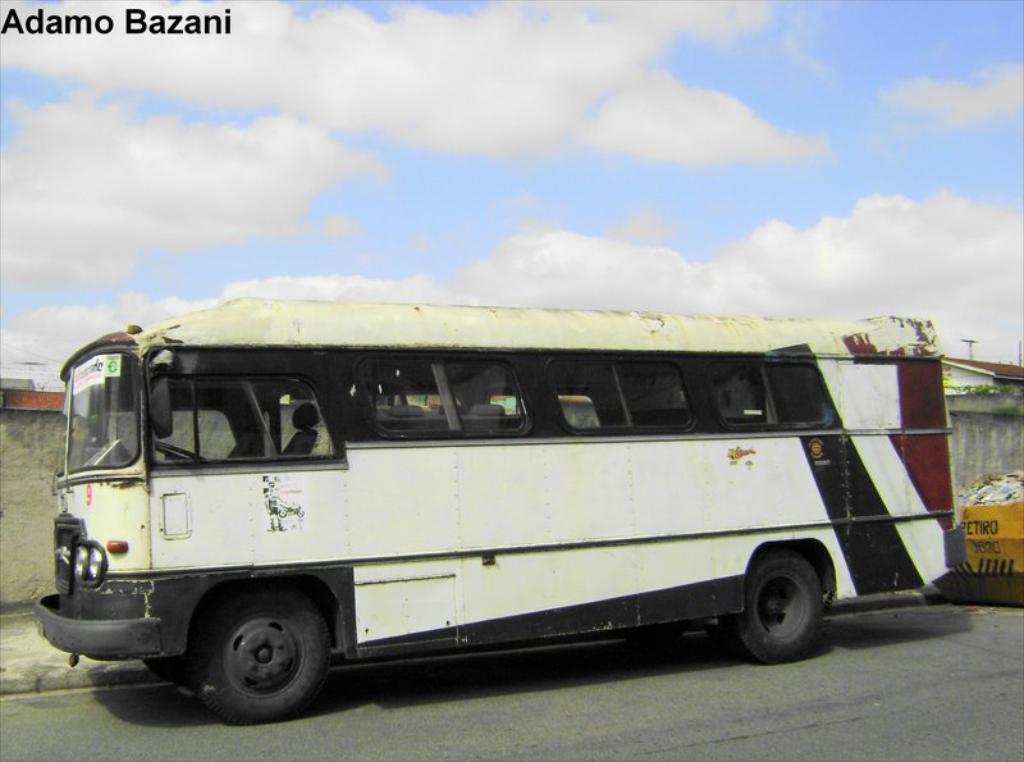Could you give a brief overview of what you see in this image? In this image in the middle there is a bus. At the bottom there is a road. In the background there are houses, wall, garbage, sky, clouds and text. 